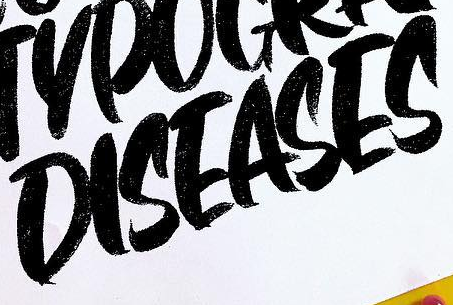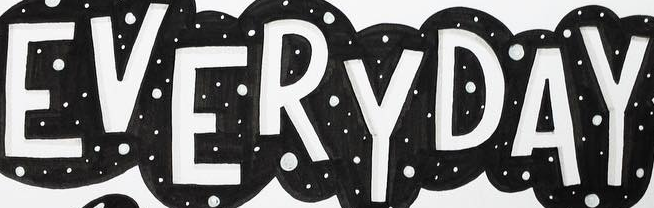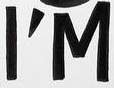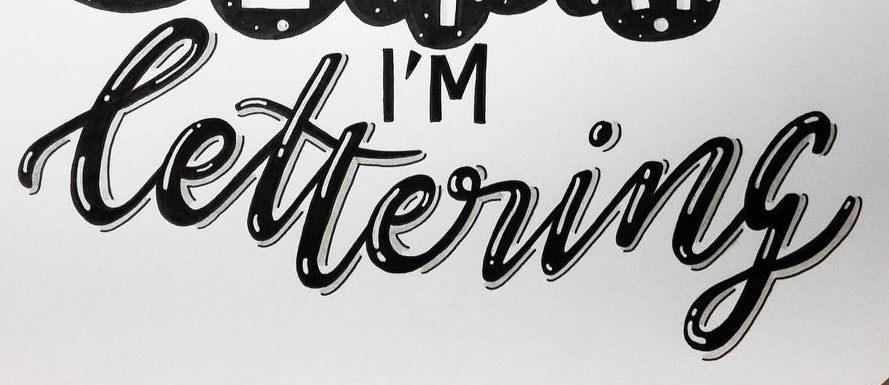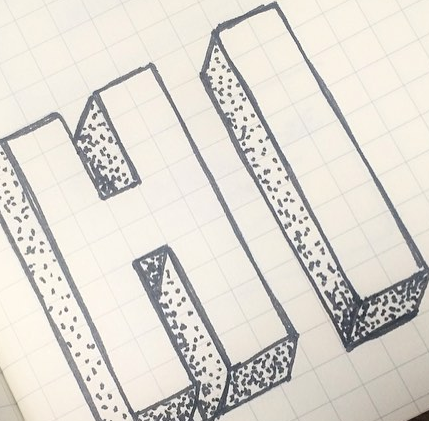What text is displayed in these images sequentially, separated by a semicolon? DISEASES; EVERYDAY; I'M; lettering; HI 